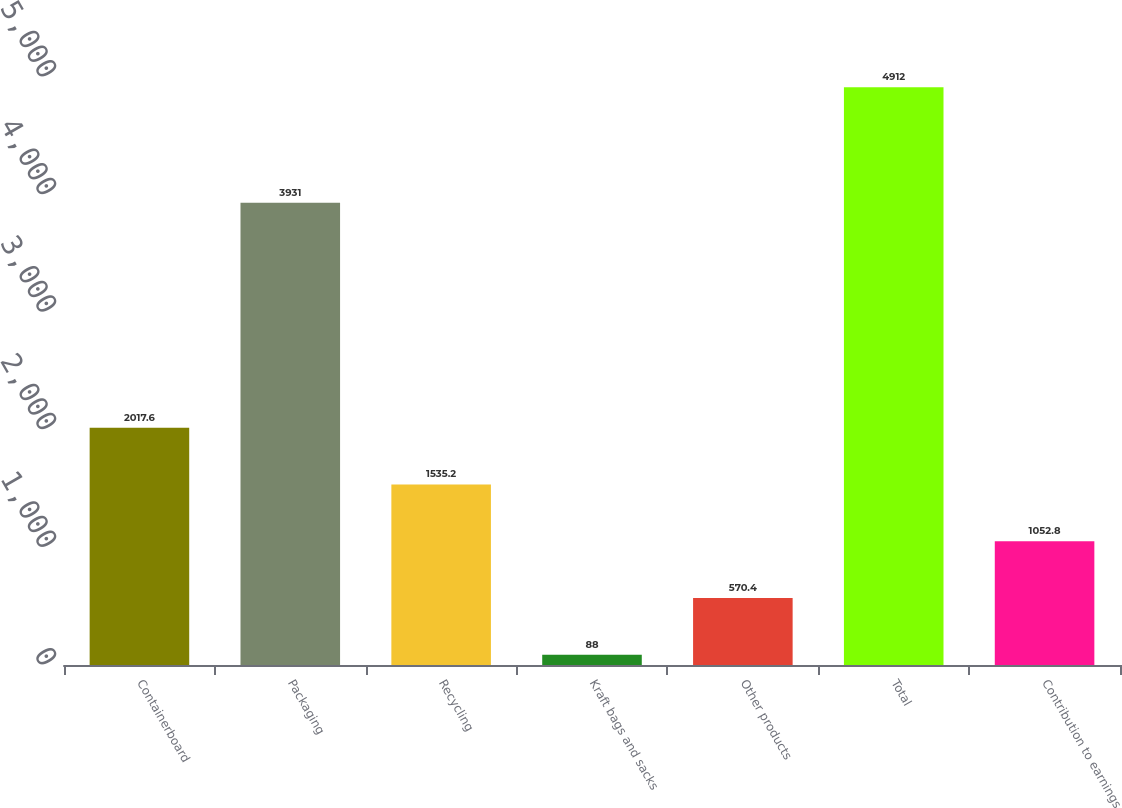Convert chart to OTSL. <chart><loc_0><loc_0><loc_500><loc_500><bar_chart><fcel>Containerboard<fcel>Packaging<fcel>Recycling<fcel>Kraft bags and sacks<fcel>Other products<fcel>Total<fcel>Contribution to earnings<nl><fcel>2017.6<fcel>3931<fcel>1535.2<fcel>88<fcel>570.4<fcel>4912<fcel>1052.8<nl></chart> 